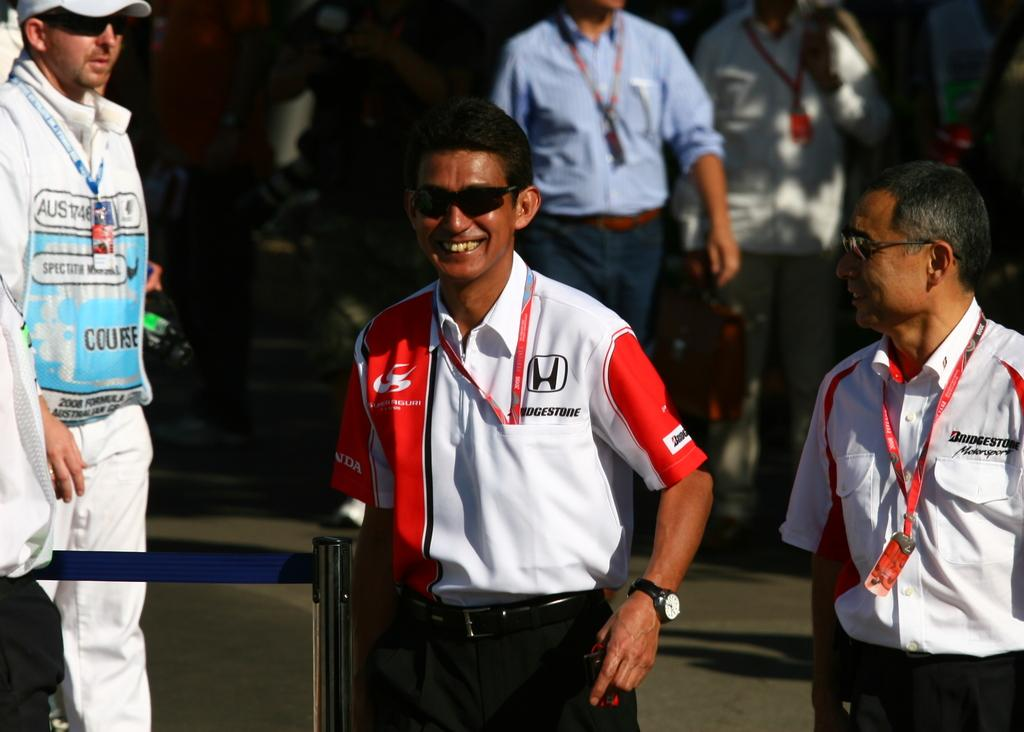<image>
Create a compact narrative representing the image presented. A man in a red and white shirt with the honda logo on his chest. 